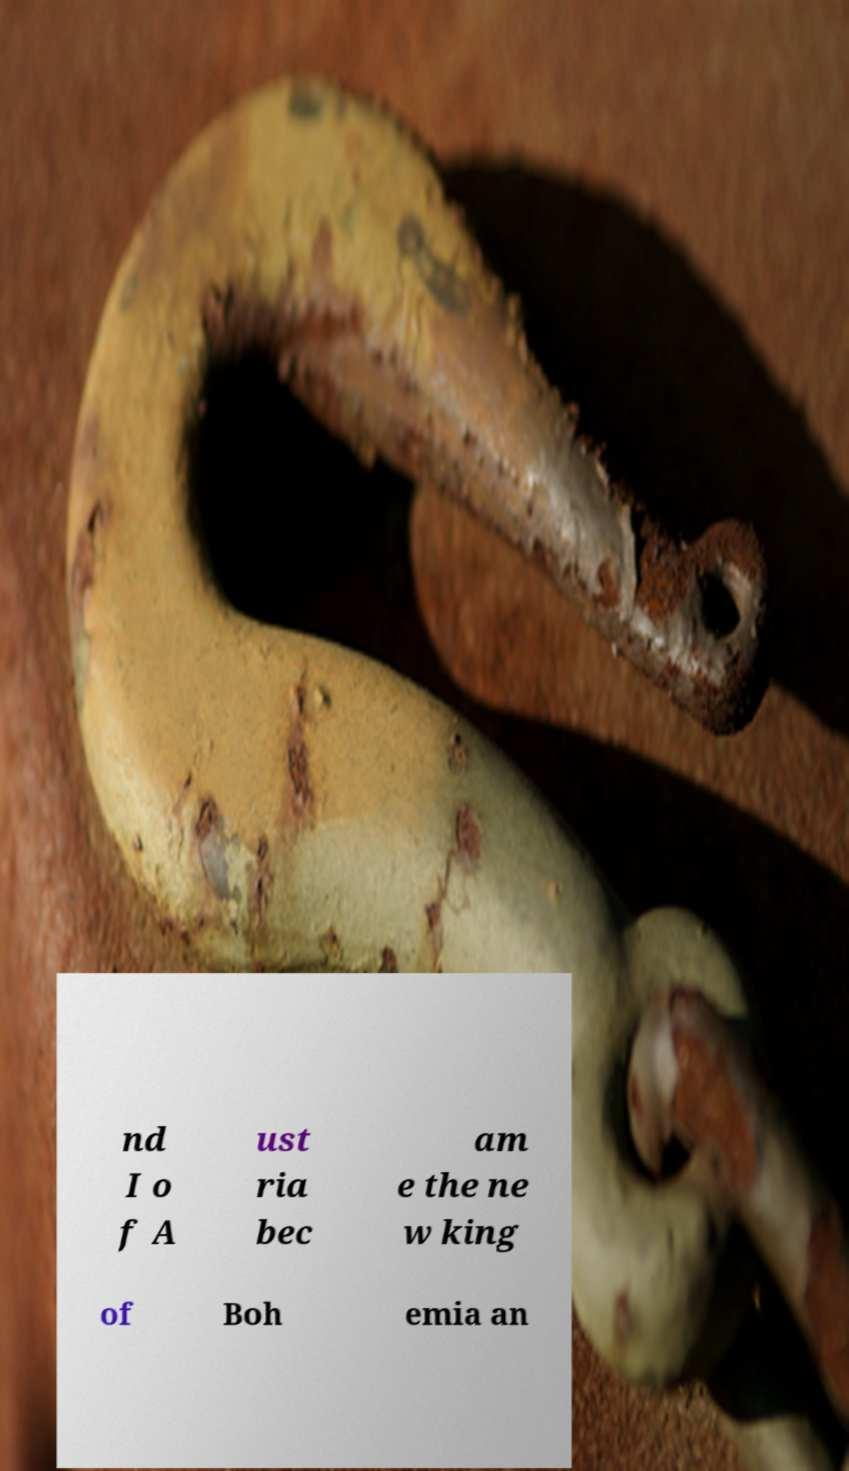Please read and relay the text visible in this image. What does it say? nd I o f A ust ria bec am e the ne w king of Boh emia an 